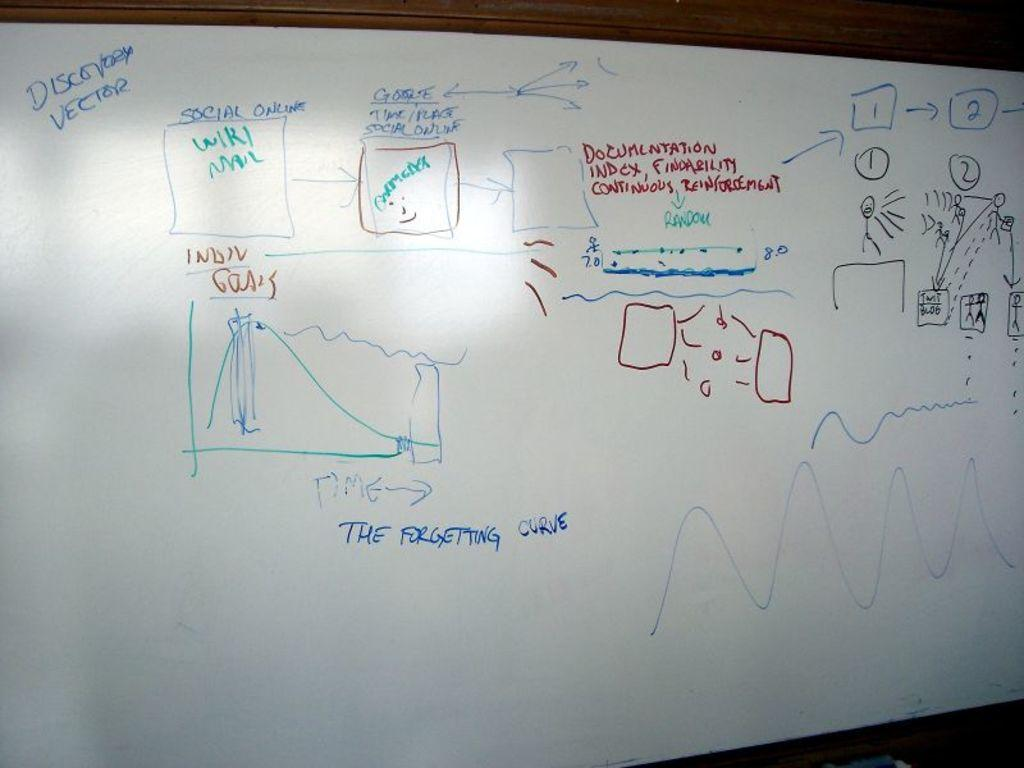<image>
Write a terse but informative summary of the picture. A whiteboard with various diagrams and notations drawn on it discussing things such as a discovery vector and the forgetting curve. 